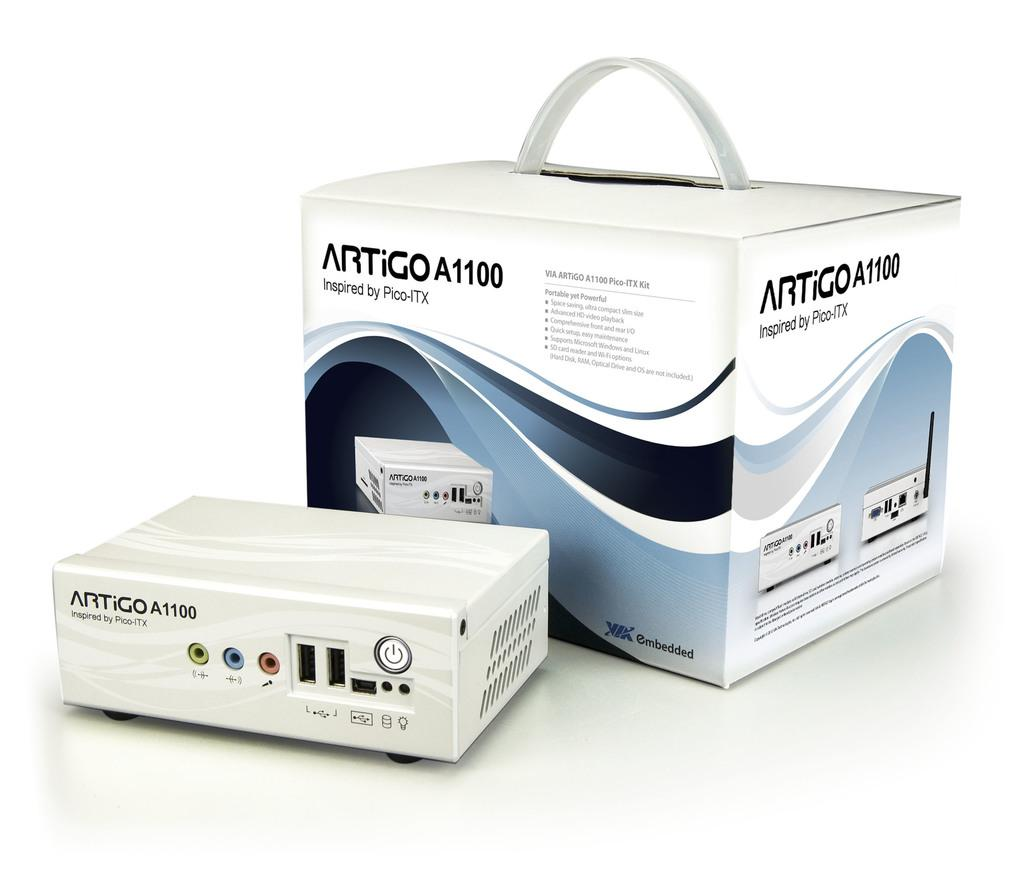Provide a one-sentence caption for the provided image. A white Artigo A1100 sits in front of its box. 